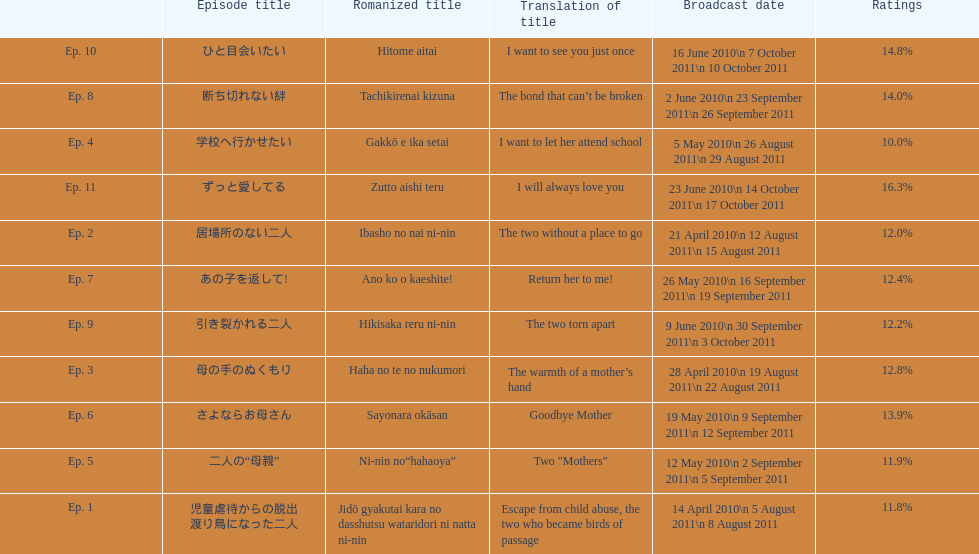Which episode of this show received the best ratings? ずっと愛してる. 